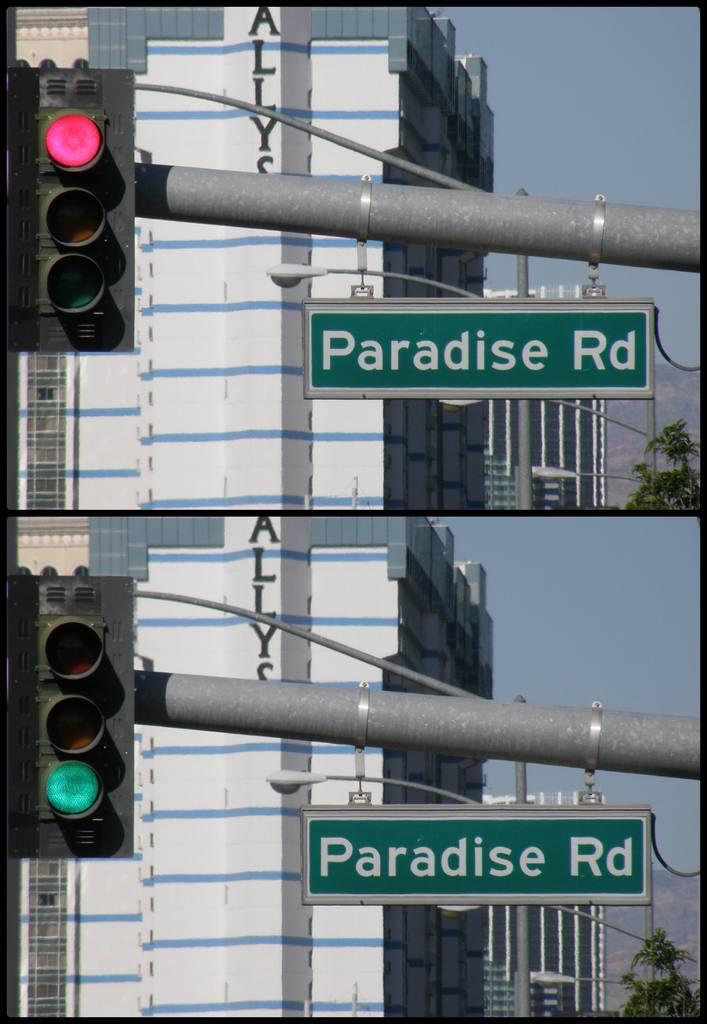What road is this?
Give a very brief answer. Paradise. What is written on the building?
Offer a terse response. Allys. 